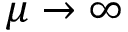<formula> <loc_0><loc_0><loc_500><loc_500>\mu \rightarrow \infty</formula> 